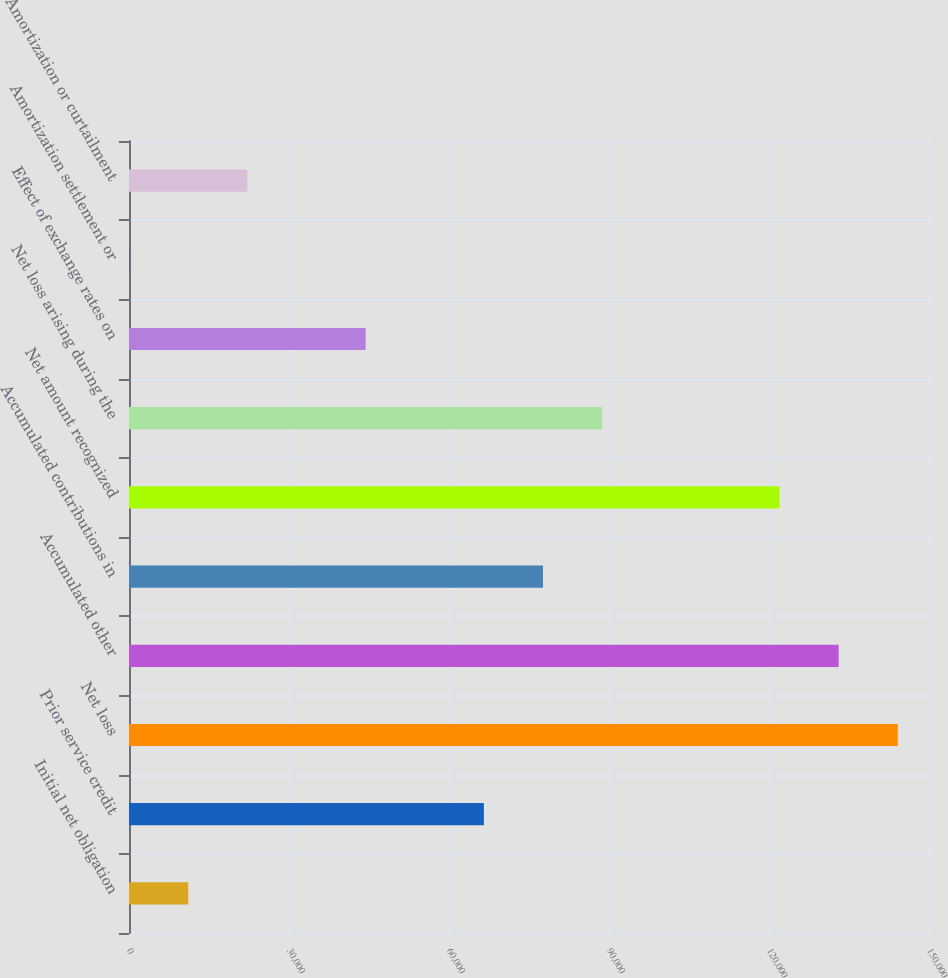Convert chart to OTSL. <chart><loc_0><loc_0><loc_500><loc_500><bar_chart><fcel>Initial net obligation<fcel>Prior service credit<fcel>Net loss<fcel>Accumulated other<fcel>Accumulated contributions in<fcel>Net amount recognized<fcel>Net loss arising during the<fcel>Effect of exchange rates on<fcel>Amortization settlement or<fcel>Amortization or curtailment<nl><fcel>11106.5<fcel>66539<fcel>144144<fcel>133058<fcel>77625.5<fcel>121972<fcel>88712<fcel>44366<fcel>20<fcel>22193<nl></chart> 